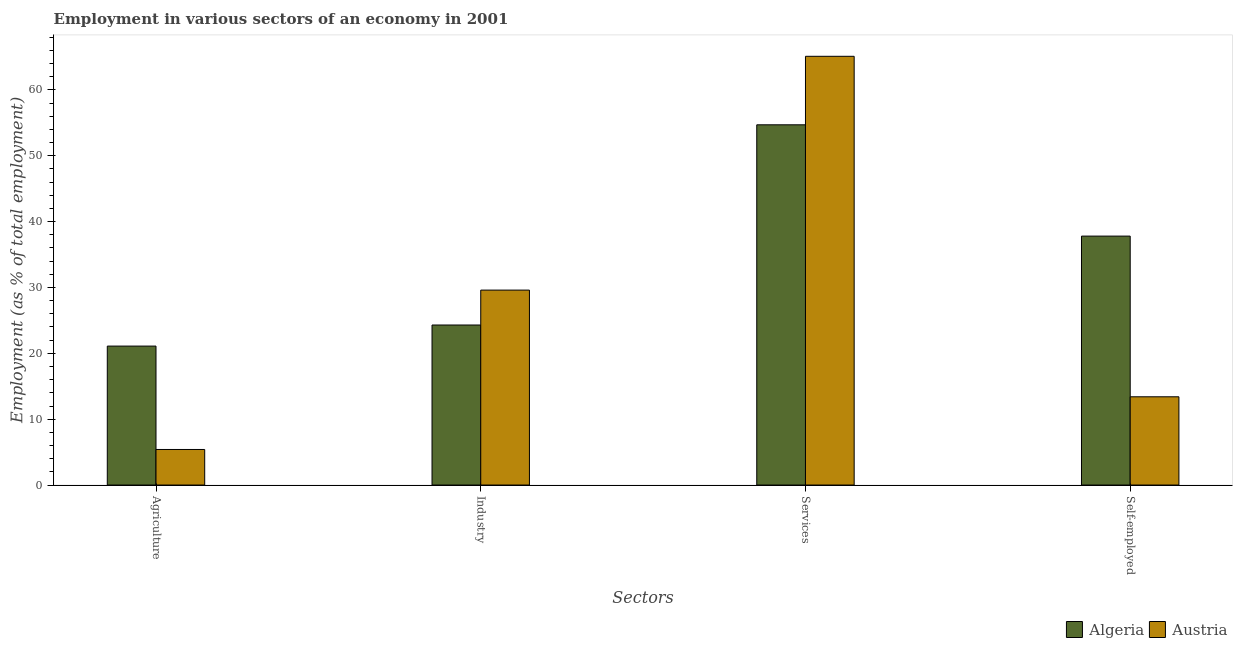Are the number of bars on each tick of the X-axis equal?
Give a very brief answer. Yes. How many bars are there on the 3rd tick from the left?
Give a very brief answer. 2. How many bars are there on the 3rd tick from the right?
Your response must be concise. 2. What is the label of the 2nd group of bars from the left?
Your answer should be very brief. Industry. What is the percentage of workers in industry in Austria?
Your answer should be very brief. 29.6. Across all countries, what is the maximum percentage of workers in services?
Ensure brevity in your answer.  65.1. Across all countries, what is the minimum percentage of workers in services?
Keep it short and to the point. 54.7. In which country was the percentage of workers in agriculture maximum?
Give a very brief answer. Algeria. In which country was the percentage of workers in services minimum?
Keep it short and to the point. Algeria. What is the total percentage of workers in industry in the graph?
Offer a terse response. 53.9. What is the difference between the percentage of workers in services in Austria and that in Algeria?
Keep it short and to the point. 10.4. What is the difference between the percentage of self employed workers in Austria and the percentage of workers in services in Algeria?
Give a very brief answer. -41.3. What is the average percentage of workers in services per country?
Your response must be concise. 59.9. What is the difference between the percentage of workers in services and percentage of self employed workers in Algeria?
Provide a short and direct response. 16.9. In how many countries, is the percentage of self employed workers greater than 62 %?
Provide a succinct answer. 0. What is the ratio of the percentage of workers in industry in Austria to that in Algeria?
Your answer should be compact. 1.22. What is the difference between the highest and the second highest percentage of workers in industry?
Provide a succinct answer. 5.3. What is the difference between the highest and the lowest percentage of workers in agriculture?
Your response must be concise. 15.7. Is the sum of the percentage of workers in industry in Austria and Algeria greater than the maximum percentage of self employed workers across all countries?
Your response must be concise. Yes. Is it the case that in every country, the sum of the percentage of self employed workers and percentage of workers in agriculture is greater than the sum of percentage of workers in industry and percentage of workers in services?
Keep it short and to the point. No. What does the 2nd bar from the left in Self-employed represents?
Make the answer very short. Austria. What does the 2nd bar from the right in Industry represents?
Your answer should be compact. Algeria. How many countries are there in the graph?
Your answer should be very brief. 2. What is the difference between two consecutive major ticks on the Y-axis?
Provide a succinct answer. 10. Does the graph contain any zero values?
Ensure brevity in your answer.  No. Does the graph contain grids?
Provide a short and direct response. No. How are the legend labels stacked?
Your answer should be compact. Horizontal. What is the title of the graph?
Provide a short and direct response. Employment in various sectors of an economy in 2001. Does "Antigua and Barbuda" appear as one of the legend labels in the graph?
Ensure brevity in your answer.  No. What is the label or title of the X-axis?
Your answer should be very brief. Sectors. What is the label or title of the Y-axis?
Provide a succinct answer. Employment (as % of total employment). What is the Employment (as % of total employment) in Algeria in Agriculture?
Your response must be concise. 21.1. What is the Employment (as % of total employment) in Austria in Agriculture?
Offer a terse response. 5.4. What is the Employment (as % of total employment) of Algeria in Industry?
Give a very brief answer. 24.3. What is the Employment (as % of total employment) of Austria in Industry?
Your response must be concise. 29.6. What is the Employment (as % of total employment) in Algeria in Services?
Make the answer very short. 54.7. What is the Employment (as % of total employment) of Austria in Services?
Ensure brevity in your answer.  65.1. What is the Employment (as % of total employment) in Algeria in Self-employed?
Provide a short and direct response. 37.8. What is the Employment (as % of total employment) of Austria in Self-employed?
Your answer should be very brief. 13.4. Across all Sectors, what is the maximum Employment (as % of total employment) in Algeria?
Ensure brevity in your answer.  54.7. Across all Sectors, what is the maximum Employment (as % of total employment) of Austria?
Offer a very short reply. 65.1. Across all Sectors, what is the minimum Employment (as % of total employment) of Algeria?
Provide a succinct answer. 21.1. Across all Sectors, what is the minimum Employment (as % of total employment) of Austria?
Offer a very short reply. 5.4. What is the total Employment (as % of total employment) of Algeria in the graph?
Ensure brevity in your answer.  137.9. What is the total Employment (as % of total employment) of Austria in the graph?
Ensure brevity in your answer.  113.5. What is the difference between the Employment (as % of total employment) in Algeria in Agriculture and that in Industry?
Ensure brevity in your answer.  -3.2. What is the difference between the Employment (as % of total employment) in Austria in Agriculture and that in Industry?
Give a very brief answer. -24.2. What is the difference between the Employment (as % of total employment) in Algeria in Agriculture and that in Services?
Offer a very short reply. -33.6. What is the difference between the Employment (as % of total employment) of Austria in Agriculture and that in Services?
Ensure brevity in your answer.  -59.7. What is the difference between the Employment (as % of total employment) of Algeria in Agriculture and that in Self-employed?
Your answer should be compact. -16.7. What is the difference between the Employment (as % of total employment) of Algeria in Industry and that in Services?
Ensure brevity in your answer.  -30.4. What is the difference between the Employment (as % of total employment) of Austria in Industry and that in Services?
Provide a short and direct response. -35.5. What is the difference between the Employment (as % of total employment) of Algeria in Industry and that in Self-employed?
Offer a very short reply. -13.5. What is the difference between the Employment (as % of total employment) in Algeria in Services and that in Self-employed?
Your response must be concise. 16.9. What is the difference between the Employment (as % of total employment) in Austria in Services and that in Self-employed?
Ensure brevity in your answer.  51.7. What is the difference between the Employment (as % of total employment) in Algeria in Agriculture and the Employment (as % of total employment) in Austria in Services?
Your response must be concise. -44. What is the difference between the Employment (as % of total employment) of Algeria in Industry and the Employment (as % of total employment) of Austria in Services?
Give a very brief answer. -40.8. What is the difference between the Employment (as % of total employment) of Algeria in Services and the Employment (as % of total employment) of Austria in Self-employed?
Your answer should be compact. 41.3. What is the average Employment (as % of total employment) in Algeria per Sectors?
Provide a succinct answer. 34.48. What is the average Employment (as % of total employment) of Austria per Sectors?
Offer a very short reply. 28.38. What is the difference between the Employment (as % of total employment) of Algeria and Employment (as % of total employment) of Austria in Services?
Provide a succinct answer. -10.4. What is the difference between the Employment (as % of total employment) of Algeria and Employment (as % of total employment) of Austria in Self-employed?
Provide a succinct answer. 24.4. What is the ratio of the Employment (as % of total employment) in Algeria in Agriculture to that in Industry?
Provide a short and direct response. 0.87. What is the ratio of the Employment (as % of total employment) in Austria in Agriculture to that in Industry?
Give a very brief answer. 0.18. What is the ratio of the Employment (as % of total employment) of Algeria in Agriculture to that in Services?
Your response must be concise. 0.39. What is the ratio of the Employment (as % of total employment) of Austria in Agriculture to that in Services?
Offer a very short reply. 0.08. What is the ratio of the Employment (as % of total employment) in Algeria in Agriculture to that in Self-employed?
Your answer should be compact. 0.56. What is the ratio of the Employment (as % of total employment) of Austria in Agriculture to that in Self-employed?
Your answer should be compact. 0.4. What is the ratio of the Employment (as % of total employment) of Algeria in Industry to that in Services?
Ensure brevity in your answer.  0.44. What is the ratio of the Employment (as % of total employment) of Austria in Industry to that in Services?
Provide a short and direct response. 0.45. What is the ratio of the Employment (as % of total employment) of Algeria in Industry to that in Self-employed?
Your answer should be compact. 0.64. What is the ratio of the Employment (as % of total employment) of Austria in Industry to that in Self-employed?
Offer a very short reply. 2.21. What is the ratio of the Employment (as % of total employment) in Algeria in Services to that in Self-employed?
Your response must be concise. 1.45. What is the ratio of the Employment (as % of total employment) of Austria in Services to that in Self-employed?
Your response must be concise. 4.86. What is the difference between the highest and the second highest Employment (as % of total employment) in Austria?
Keep it short and to the point. 35.5. What is the difference between the highest and the lowest Employment (as % of total employment) of Algeria?
Your response must be concise. 33.6. What is the difference between the highest and the lowest Employment (as % of total employment) of Austria?
Ensure brevity in your answer.  59.7. 